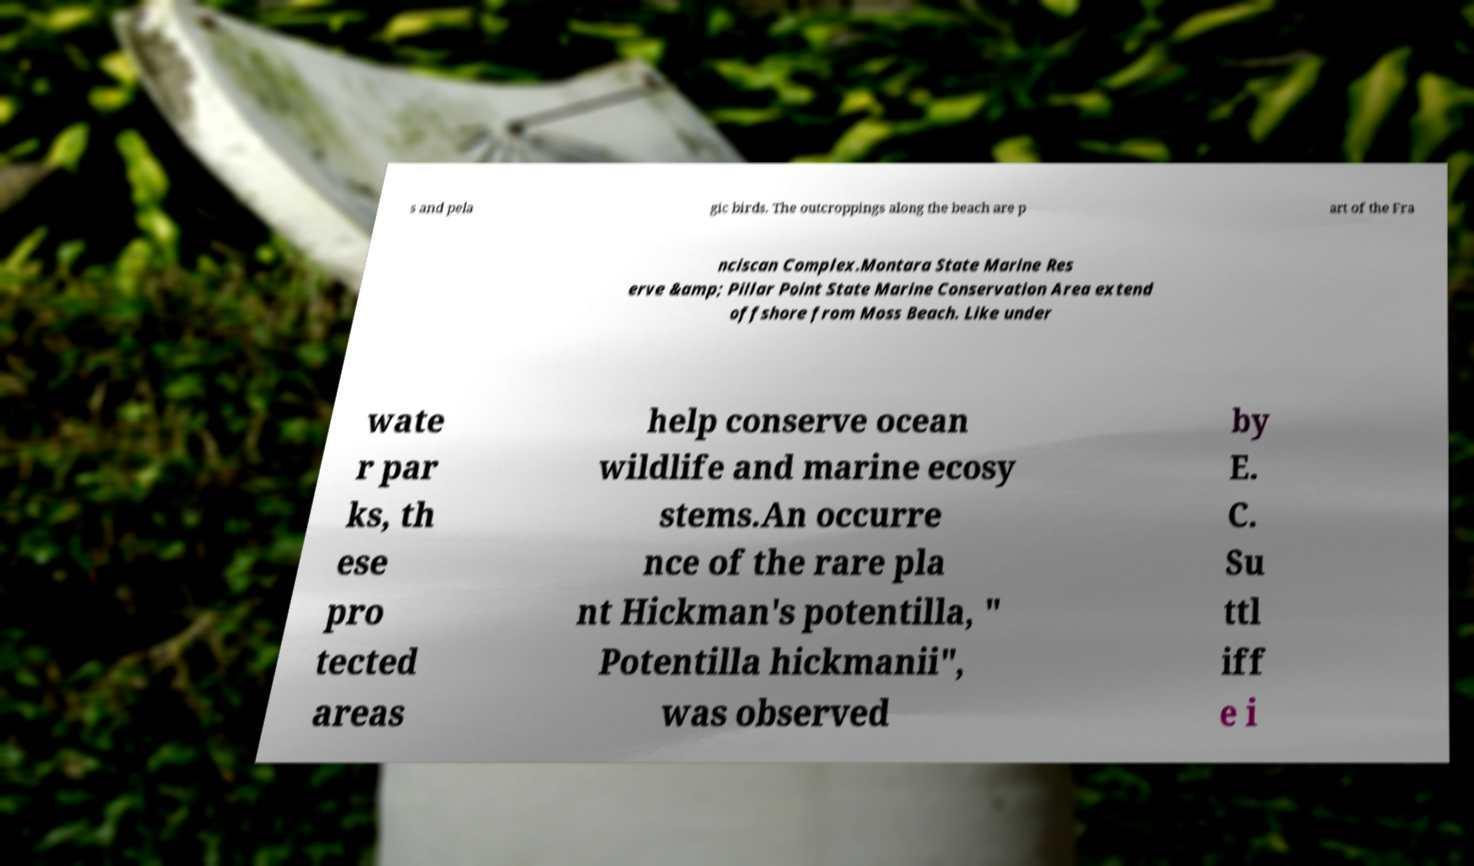Could you extract and type out the text from this image? s and pela gic birds. The outcroppings along the beach are p art of the Fra nciscan Complex.Montara State Marine Res erve &amp; Pillar Point State Marine Conservation Area extend offshore from Moss Beach. Like under wate r par ks, th ese pro tected areas help conserve ocean wildlife and marine ecosy stems.An occurre nce of the rare pla nt Hickman's potentilla, " Potentilla hickmanii", was observed by E. C. Su ttl iff e i 